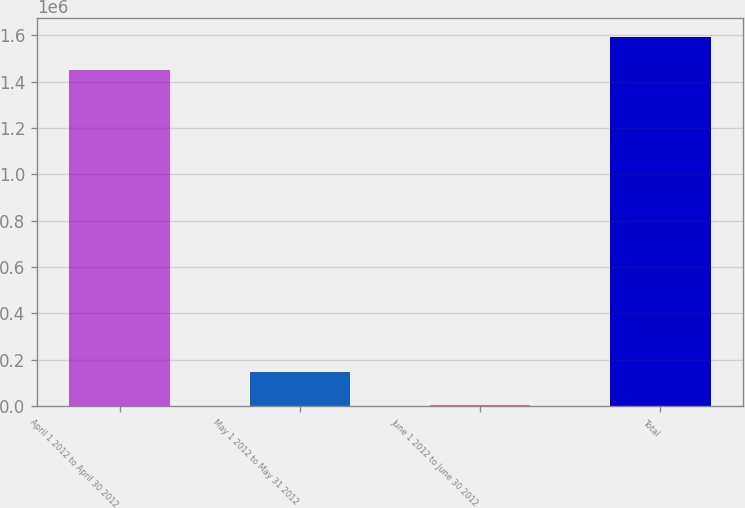Convert chart to OTSL. <chart><loc_0><loc_0><loc_500><loc_500><bar_chart><fcel>April 1 2012 to April 30 2012<fcel>May 1 2012 to May 31 2012<fcel>June 1 2012 to June 30 2012<fcel>Total<nl><fcel>1.44809e+06<fcel>148649<fcel>2729<fcel>1.59401e+06<nl></chart> 